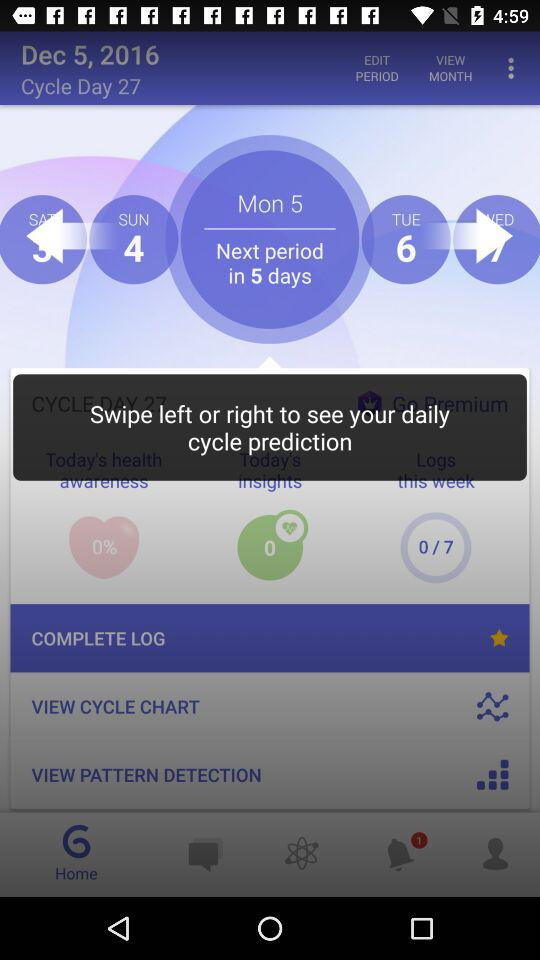How many days are there left until the next period?
Answer the question using a single word or phrase. 5 days 